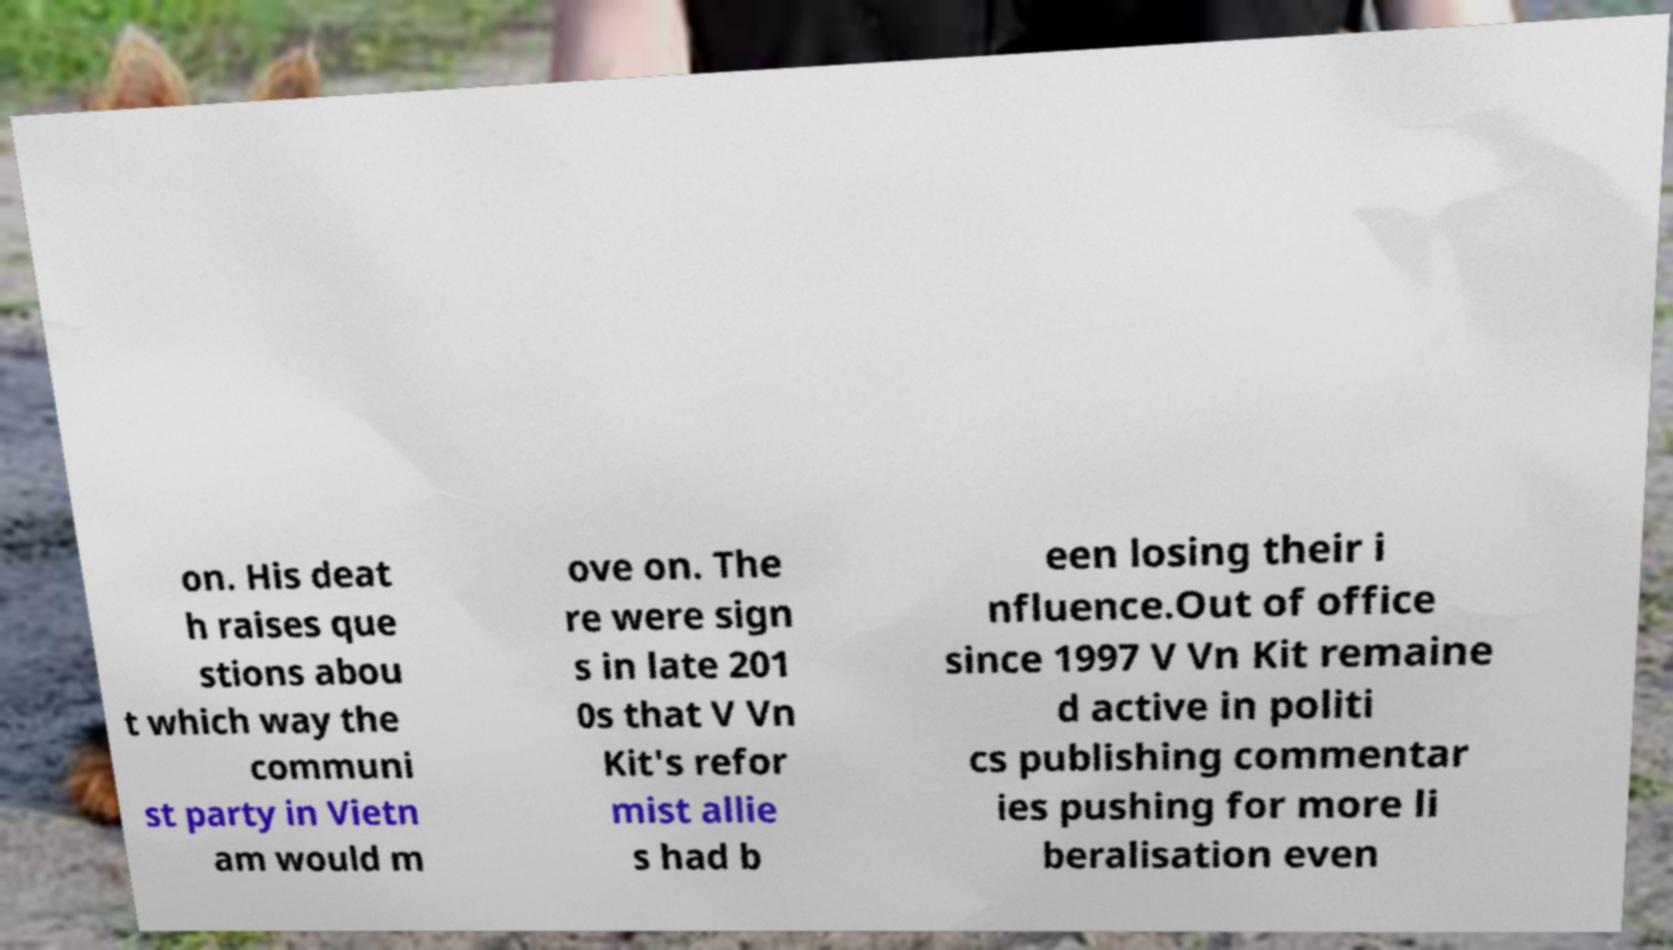Can you read and provide the text displayed in the image?This photo seems to have some interesting text. Can you extract and type it out for me? on. His deat h raises que stions abou t which way the communi st party in Vietn am would m ove on. The re were sign s in late 201 0s that V Vn Kit's refor mist allie s had b een losing their i nfluence.Out of office since 1997 V Vn Kit remaine d active in politi cs publishing commentar ies pushing for more li beralisation even 